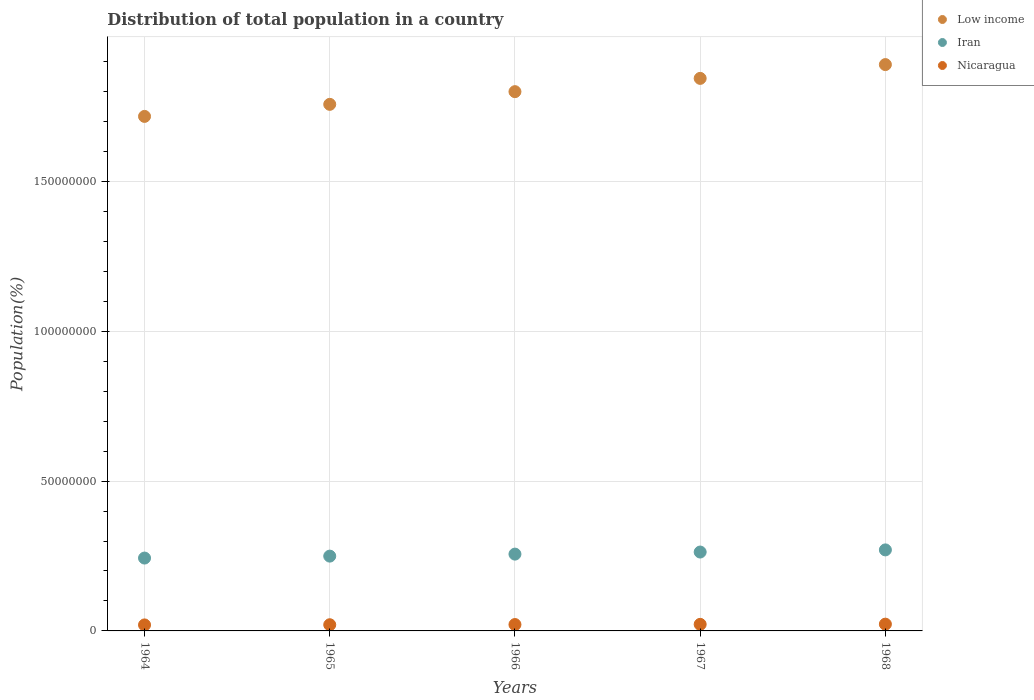Is the number of dotlines equal to the number of legend labels?
Your answer should be very brief. Yes. What is the population of in Nicaragua in 1964?
Your answer should be very brief. 2.00e+06. Across all years, what is the maximum population of in Nicaragua?
Provide a short and direct response. 2.26e+06. Across all years, what is the minimum population of in Iran?
Your answer should be compact. 2.43e+07. In which year was the population of in Nicaragua maximum?
Make the answer very short. 1968. In which year was the population of in Low income minimum?
Provide a short and direct response. 1964. What is the total population of in Low income in the graph?
Keep it short and to the point. 9.01e+08. What is the difference between the population of in Low income in 1965 and that in 1968?
Give a very brief answer. -1.33e+07. What is the difference between the population of in Iran in 1966 and the population of in Nicaragua in 1967?
Your response must be concise. 2.34e+07. What is the average population of in Nicaragua per year?
Your response must be concise. 2.13e+06. In the year 1966, what is the difference between the population of in Iran and population of in Nicaragua?
Your answer should be very brief. 2.35e+07. What is the ratio of the population of in Iran in 1966 to that in 1967?
Your answer should be very brief. 0.97. Is the population of in Low income in 1965 less than that in 1967?
Give a very brief answer. Yes. What is the difference between the highest and the second highest population of in Low income?
Offer a very short reply. 4.60e+06. What is the difference between the highest and the lowest population of in Iran?
Offer a very short reply. 2.72e+06. In how many years, is the population of in Iran greater than the average population of in Iran taken over all years?
Give a very brief answer. 2. Does the population of in Low income monotonically increase over the years?
Provide a short and direct response. Yes. What is the difference between two consecutive major ticks on the Y-axis?
Offer a very short reply. 5.00e+07. Are the values on the major ticks of Y-axis written in scientific E-notation?
Keep it short and to the point. No. Where does the legend appear in the graph?
Give a very brief answer. Top right. How many legend labels are there?
Offer a very short reply. 3. How are the legend labels stacked?
Your response must be concise. Vertical. What is the title of the graph?
Make the answer very short. Distribution of total population in a country. What is the label or title of the X-axis?
Provide a short and direct response. Years. What is the label or title of the Y-axis?
Your response must be concise. Population(%). What is the Population(%) in Low income in 1964?
Ensure brevity in your answer.  1.72e+08. What is the Population(%) in Iran in 1964?
Your answer should be very brief. 2.43e+07. What is the Population(%) in Nicaragua in 1964?
Make the answer very short. 2.00e+06. What is the Population(%) in Low income in 1965?
Your response must be concise. 1.76e+08. What is the Population(%) in Iran in 1965?
Make the answer very short. 2.50e+07. What is the Population(%) of Nicaragua in 1965?
Keep it short and to the point. 2.06e+06. What is the Population(%) in Low income in 1966?
Keep it short and to the point. 1.80e+08. What is the Population(%) in Iran in 1966?
Ensure brevity in your answer.  2.56e+07. What is the Population(%) of Nicaragua in 1966?
Provide a short and direct response. 2.13e+06. What is the Population(%) of Low income in 1967?
Provide a short and direct response. 1.84e+08. What is the Population(%) in Iran in 1967?
Offer a very short reply. 2.63e+07. What is the Population(%) in Nicaragua in 1967?
Ensure brevity in your answer.  2.19e+06. What is the Population(%) in Low income in 1968?
Provide a short and direct response. 1.89e+08. What is the Population(%) in Iran in 1968?
Your answer should be very brief. 2.70e+07. What is the Population(%) of Nicaragua in 1968?
Keep it short and to the point. 2.26e+06. Across all years, what is the maximum Population(%) in Low income?
Offer a very short reply. 1.89e+08. Across all years, what is the maximum Population(%) in Iran?
Give a very brief answer. 2.70e+07. Across all years, what is the maximum Population(%) in Nicaragua?
Ensure brevity in your answer.  2.26e+06. Across all years, what is the minimum Population(%) of Low income?
Give a very brief answer. 1.72e+08. Across all years, what is the minimum Population(%) of Iran?
Give a very brief answer. 2.43e+07. Across all years, what is the minimum Population(%) in Nicaragua?
Your response must be concise. 2.00e+06. What is the total Population(%) in Low income in the graph?
Provide a short and direct response. 9.01e+08. What is the total Population(%) in Iran in the graph?
Offer a very short reply. 1.28e+08. What is the total Population(%) of Nicaragua in the graph?
Your answer should be compact. 1.06e+07. What is the difference between the Population(%) of Low income in 1964 and that in 1965?
Keep it short and to the point. -4.03e+06. What is the difference between the Population(%) in Iran in 1964 and that in 1965?
Provide a short and direct response. -6.47e+05. What is the difference between the Population(%) of Nicaragua in 1964 and that in 1965?
Your answer should be compact. -6.05e+04. What is the difference between the Population(%) in Low income in 1964 and that in 1966?
Offer a terse response. -8.26e+06. What is the difference between the Population(%) in Iran in 1964 and that in 1966?
Offer a terse response. -1.32e+06. What is the difference between the Population(%) in Nicaragua in 1964 and that in 1966?
Provide a succinct answer. -1.23e+05. What is the difference between the Population(%) of Low income in 1964 and that in 1967?
Your response must be concise. -1.27e+07. What is the difference between the Population(%) of Iran in 1964 and that in 1967?
Provide a succinct answer. -2.01e+06. What is the difference between the Population(%) of Nicaragua in 1964 and that in 1967?
Offer a terse response. -1.88e+05. What is the difference between the Population(%) in Low income in 1964 and that in 1968?
Give a very brief answer. -1.73e+07. What is the difference between the Population(%) of Iran in 1964 and that in 1968?
Offer a very short reply. -2.72e+06. What is the difference between the Population(%) of Nicaragua in 1964 and that in 1968?
Keep it short and to the point. -2.55e+05. What is the difference between the Population(%) of Low income in 1965 and that in 1966?
Make the answer very short. -4.23e+06. What is the difference between the Population(%) of Iran in 1965 and that in 1966?
Provide a succinct answer. -6.70e+05. What is the difference between the Population(%) in Nicaragua in 1965 and that in 1966?
Offer a terse response. -6.26e+04. What is the difference between the Population(%) of Low income in 1965 and that in 1967?
Offer a very short reply. -8.66e+06. What is the difference between the Population(%) of Iran in 1965 and that in 1967?
Provide a succinct answer. -1.36e+06. What is the difference between the Population(%) in Nicaragua in 1965 and that in 1967?
Provide a succinct answer. -1.27e+05. What is the difference between the Population(%) of Low income in 1965 and that in 1968?
Your answer should be very brief. -1.33e+07. What is the difference between the Population(%) in Iran in 1965 and that in 1968?
Your answer should be compact. -2.08e+06. What is the difference between the Population(%) in Nicaragua in 1965 and that in 1968?
Offer a terse response. -1.94e+05. What is the difference between the Population(%) in Low income in 1966 and that in 1967?
Give a very brief answer. -4.43e+06. What is the difference between the Population(%) of Iran in 1966 and that in 1967?
Offer a terse response. -6.93e+05. What is the difference between the Population(%) of Nicaragua in 1966 and that in 1967?
Provide a succinct answer. -6.46e+04. What is the difference between the Population(%) in Low income in 1966 and that in 1968?
Provide a succinct answer. -9.03e+06. What is the difference between the Population(%) of Iran in 1966 and that in 1968?
Offer a terse response. -1.41e+06. What is the difference between the Population(%) in Nicaragua in 1966 and that in 1968?
Make the answer very short. -1.32e+05. What is the difference between the Population(%) of Low income in 1967 and that in 1968?
Offer a terse response. -4.60e+06. What is the difference between the Population(%) of Iran in 1967 and that in 1968?
Keep it short and to the point. -7.15e+05. What is the difference between the Population(%) in Nicaragua in 1967 and that in 1968?
Your answer should be very brief. -6.69e+04. What is the difference between the Population(%) of Low income in 1964 and the Population(%) of Iran in 1965?
Your response must be concise. 1.47e+08. What is the difference between the Population(%) of Low income in 1964 and the Population(%) of Nicaragua in 1965?
Make the answer very short. 1.70e+08. What is the difference between the Population(%) in Iran in 1964 and the Population(%) in Nicaragua in 1965?
Ensure brevity in your answer.  2.22e+07. What is the difference between the Population(%) of Low income in 1964 and the Population(%) of Iran in 1966?
Your response must be concise. 1.46e+08. What is the difference between the Population(%) in Low income in 1964 and the Population(%) in Nicaragua in 1966?
Offer a very short reply. 1.70e+08. What is the difference between the Population(%) of Iran in 1964 and the Population(%) of Nicaragua in 1966?
Offer a very short reply. 2.22e+07. What is the difference between the Population(%) in Low income in 1964 and the Population(%) in Iran in 1967?
Offer a terse response. 1.45e+08. What is the difference between the Population(%) of Low income in 1964 and the Population(%) of Nicaragua in 1967?
Your answer should be very brief. 1.69e+08. What is the difference between the Population(%) of Iran in 1964 and the Population(%) of Nicaragua in 1967?
Give a very brief answer. 2.21e+07. What is the difference between the Population(%) in Low income in 1964 and the Population(%) in Iran in 1968?
Give a very brief answer. 1.45e+08. What is the difference between the Population(%) in Low income in 1964 and the Population(%) in Nicaragua in 1968?
Your answer should be compact. 1.69e+08. What is the difference between the Population(%) of Iran in 1964 and the Population(%) of Nicaragua in 1968?
Ensure brevity in your answer.  2.21e+07. What is the difference between the Population(%) in Low income in 1965 and the Population(%) in Iran in 1966?
Offer a terse response. 1.50e+08. What is the difference between the Population(%) in Low income in 1965 and the Population(%) in Nicaragua in 1966?
Make the answer very short. 1.74e+08. What is the difference between the Population(%) in Iran in 1965 and the Population(%) in Nicaragua in 1966?
Provide a succinct answer. 2.28e+07. What is the difference between the Population(%) of Low income in 1965 and the Population(%) of Iran in 1967?
Provide a short and direct response. 1.49e+08. What is the difference between the Population(%) in Low income in 1965 and the Population(%) in Nicaragua in 1967?
Give a very brief answer. 1.73e+08. What is the difference between the Population(%) in Iran in 1965 and the Population(%) in Nicaragua in 1967?
Make the answer very short. 2.28e+07. What is the difference between the Population(%) of Low income in 1965 and the Population(%) of Iran in 1968?
Provide a succinct answer. 1.49e+08. What is the difference between the Population(%) in Low income in 1965 and the Population(%) in Nicaragua in 1968?
Offer a terse response. 1.73e+08. What is the difference between the Population(%) in Iran in 1965 and the Population(%) in Nicaragua in 1968?
Your answer should be very brief. 2.27e+07. What is the difference between the Population(%) in Low income in 1966 and the Population(%) in Iran in 1967?
Your answer should be very brief. 1.54e+08. What is the difference between the Population(%) in Low income in 1966 and the Population(%) in Nicaragua in 1967?
Offer a terse response. 1.78e+08. What is the difference between the Population(%) in Iran in 1966 and the Population(%) in Nicaragua in 1967?
Ensure brevity in your answer.  2.34e+07. What is the difference between the Population(%) of Low income in 1966 and the Population(%) of Iran in 1968?
Give a very brief answer. 1.53e+08. What is the difference between the Population(%) in Low income in 1966 and the Population(%) in Nicaragua in 1968?
Keep it short and to the point. 1.78e+08. What is the difference between the Population(%) in Iran in 1966 and the Population(%) in Nicaragua in 1968?
Offer a very short reply. 2.34e+07. What is the difference between the Population(%) of Low income in 1967 and the Population(%) of Iran in 1968?
Offer a very short reply. 1.57e+08. What is the difference between the Population(%) of Low income in 1967 and the Population(%) of Nicaragua in 1968?
Offer a terse response. 1.82e+08. What is the difference between the Population(%) in Iran in 1967 and the Population(%) in Nicaragua in 1968?
Your answer should be very brief. 2.41e+07. What is the average Population(%) in Low income per year?
Provide a succinct answer. 1.80e+08. What is the average Population(%) in Iran per year?
Provide a short and direct response. 2.56e+07. What is the average Population(%) in Nicaragua per year?
Give a very brief answer. 2.13e+06. In the year 1964, what is the difference between the Population(%) of Low income and Population(%) of Iran?
Offer a very short reply. 1.47e+08. In the year 1964, what is the difference between the Population(%) in Low income and Population(%) in Nicaragua?
Your answer should be compact. 1.70e+08. In the year 1964, what is the difference between the Population(%) in Iran and Population(%) in Nicaragua?
Provide a succinct answer. 2.23e+07. In the year 1965, what is the difference between the Population(%) of Low income and Population(%) of Iran?
Offer a very short reply. 1.51e+08. In the year 1965, what is the difference between the Population(%) of Low income and Population(%) of Nicaragua?
Your answer should be very brief. 1.74e+08. In the year 1965, what is the difference between the Population(%) of Iran and Population(%) of Nicaragua?
Give a very brief answer. 2.29e+07. In the year 1966, what is the difference between the Population(%) in Low income and Population(%) in Iran?
Your answer should be very brief. 1.54e+08. In the year 1966, what is the difference between the Population(%) of Low income and Population(%) of Nicaragua?
Give a very brief answer. 1.78e+08. In the year 1966, what is the difference between the Population(%) of Iran and Population(%) of Nicaragua?
Offer a very short reply. 2.35e+07. In the year 1967, what is the difference between the Population(%) in Low income and Population(%) in Iran?
Provide a succinct answer. 1.58e+08. In the year 1967, what is the difference between the Population(%) in Low income and Population(%) in Nicaragua?
Make the answer very short. 1.82e+08. In the year 1967, what is the difference between the Population(%) of Iran and Population(%) of Nicaragua?
Offer a terse response. 2.41e+07. In the year 1968, what is the difference between the Population(%) of Low income and Population(%) of Iran?
Keep it short and to the point. 1.62e+08. In the year 1968, what is the difference between the Population(%) of Low income and Population(%) of Nicaragua?
Ensure brevity in your answer.  1.87e+08. In the year 1968, what is the difference between the Population(%) in Iran and Population(%) in Nicaragua?
Provide a short and direct response. 2.48e+07. What is the ratio of the Population(%) in Low income in 1964 to that in 1965?
Your answer should be very brief. 0.98. What is the ratio of the Population(%) in Iran in 1964 to that in 1965?
Offer a terse response. 0.97. What is the ratio of the Population(%) of Nicaragua in 1964 to that in 1965?
Your response must be concise. 0.97. What is the ratio of the Population(%) of Low income in 1964 to that in 1966?
Your response must be concise. 0.95. What is the ratio of the Population(%) of Iran in 1964 to that in 1966?
Your answer should be very brief. 0.95. What is the ratio of the Population(%) of Nicaragua in 1964 to that in 1966?
Make the answer very short. 0.94. What is the ratio of the Population(%) of Low income in 1964 to that in 1967?
Make the answer very short. 0.93. What is the ratio of the Population(%) in Iran in 1964 to that in 1967?
Provide a succinct answer. 0.92. What is the ratio of the Population(%) in Nicaragua in 1964 to that in 1967?
Your answer should be very brief. 0.91. What is the ratio of the Population(%) in Low income in 1964 to that in 1968?
Offer a very short reply. 0.91. What is the ratio of the Population(%) in Iran in 1964 to that in 1968?
Offer a very short reply. 0.9. What is the ratio of the Population(%) in Nicaragua in 1964 to that in 1968?
Provide a short and direct response. 0.89. What is the ratio of the Population(%) of Low income in 1965 to that in 1966?
Your response must be concise. 0.98. What is the ratio of the Population(%) in Iran in 1965 to that in 1966?
Provide a succinct answer. 0.97. What is the ratio of the Population(%) in Nicaragua in 1965 to that in 1966?
Your answer should be compact. 0.97. What is the ratio of the Population(%) in Low income in 1965 to that in 1967?
Provide a succinct answer. 0.95. What is the ratio of the Population(%) in Iran in 1965 to that in 1967?
Make the answer very short. 0.95. What is the ratio of the Population(%) of Nicaragua in 1965 to that in 1967?
Offer a very short reply. 0.94. What is the ratio of the Population(%) of Low income in 1965 to that in 1968?
Offer a very short reply. 0.93. What is the ratio of the Population(%) of Iran in 1965 to that in 1968?
Your answer should be very brief. 0.92. What is the ratio of the Population(%) in Nicaragua in 1965 to that in 1968?
Make the answer very short. 0.91. What is the ratio of the Population(%) of Low income in 1966 to that in 1967?
Make the answer very short. 0.98. What is the ratio of the Population(%) in Iran in 1966 to that in 1967?
Your answer should be very brief. 0.97. What is the ratio of the Population(%) in Nicaragua in 1966 to that in 1967?
Your response must be concise. 0.97. What is the ratio of the Population(%) of Low income in 1966 to that in 1968?
Your answer should be very brief. 0.95. What is the ratio of the Population(%) of Iran in 1966 to that in 1968?
Your response must be concise. 0.95. What is the ratio of the Population(%) in Nicaragua in 1966 to that in 1968?
Provide a short and direct response. 0.94. What is the ratio of the Population(%) in Low income in 1967 to that in 1968?
Provide a succinct answer. 0.98. What is the ratio of the Population(%) in Iran in 1967 to that in 1968?
Your response must be concise. 0.97. What is the ratio of the Population(%) of Nicaragua in 1967 to that in 1968?
Make the answer very short. 0.97. What is the difference between the highest and the second highest Population(%) of Low income?
Ensure brevity in your answer.  4.60e+06. What is the difference between the highest and the second highest Population(%) in Iran?
Offer a terse response. 7.15e+05. What is the difference between the highest and the second highest Population(%) in Nicaragua?
Ensure brevity in your answer.  6.69e+04. What is the difference between the highest and the lowest Population(%) of Low income?
Offer a very short reply. 1.73e+07. What is the difference between the highest and the lowest Population(%) of Iran?
Your answer should be compact. 2.72e+06. What is the difference between the highest and the lowest Population(%) in Nicaragua?
Provide a short and direct response. 2.55e+05. 